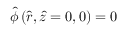<formula> <loc_0><loc_0><loc_500><loc_500>\hat { \phi } \left ( \hat { r } , \hat { z } = 0 , 0 \right ) = 0</formula> 